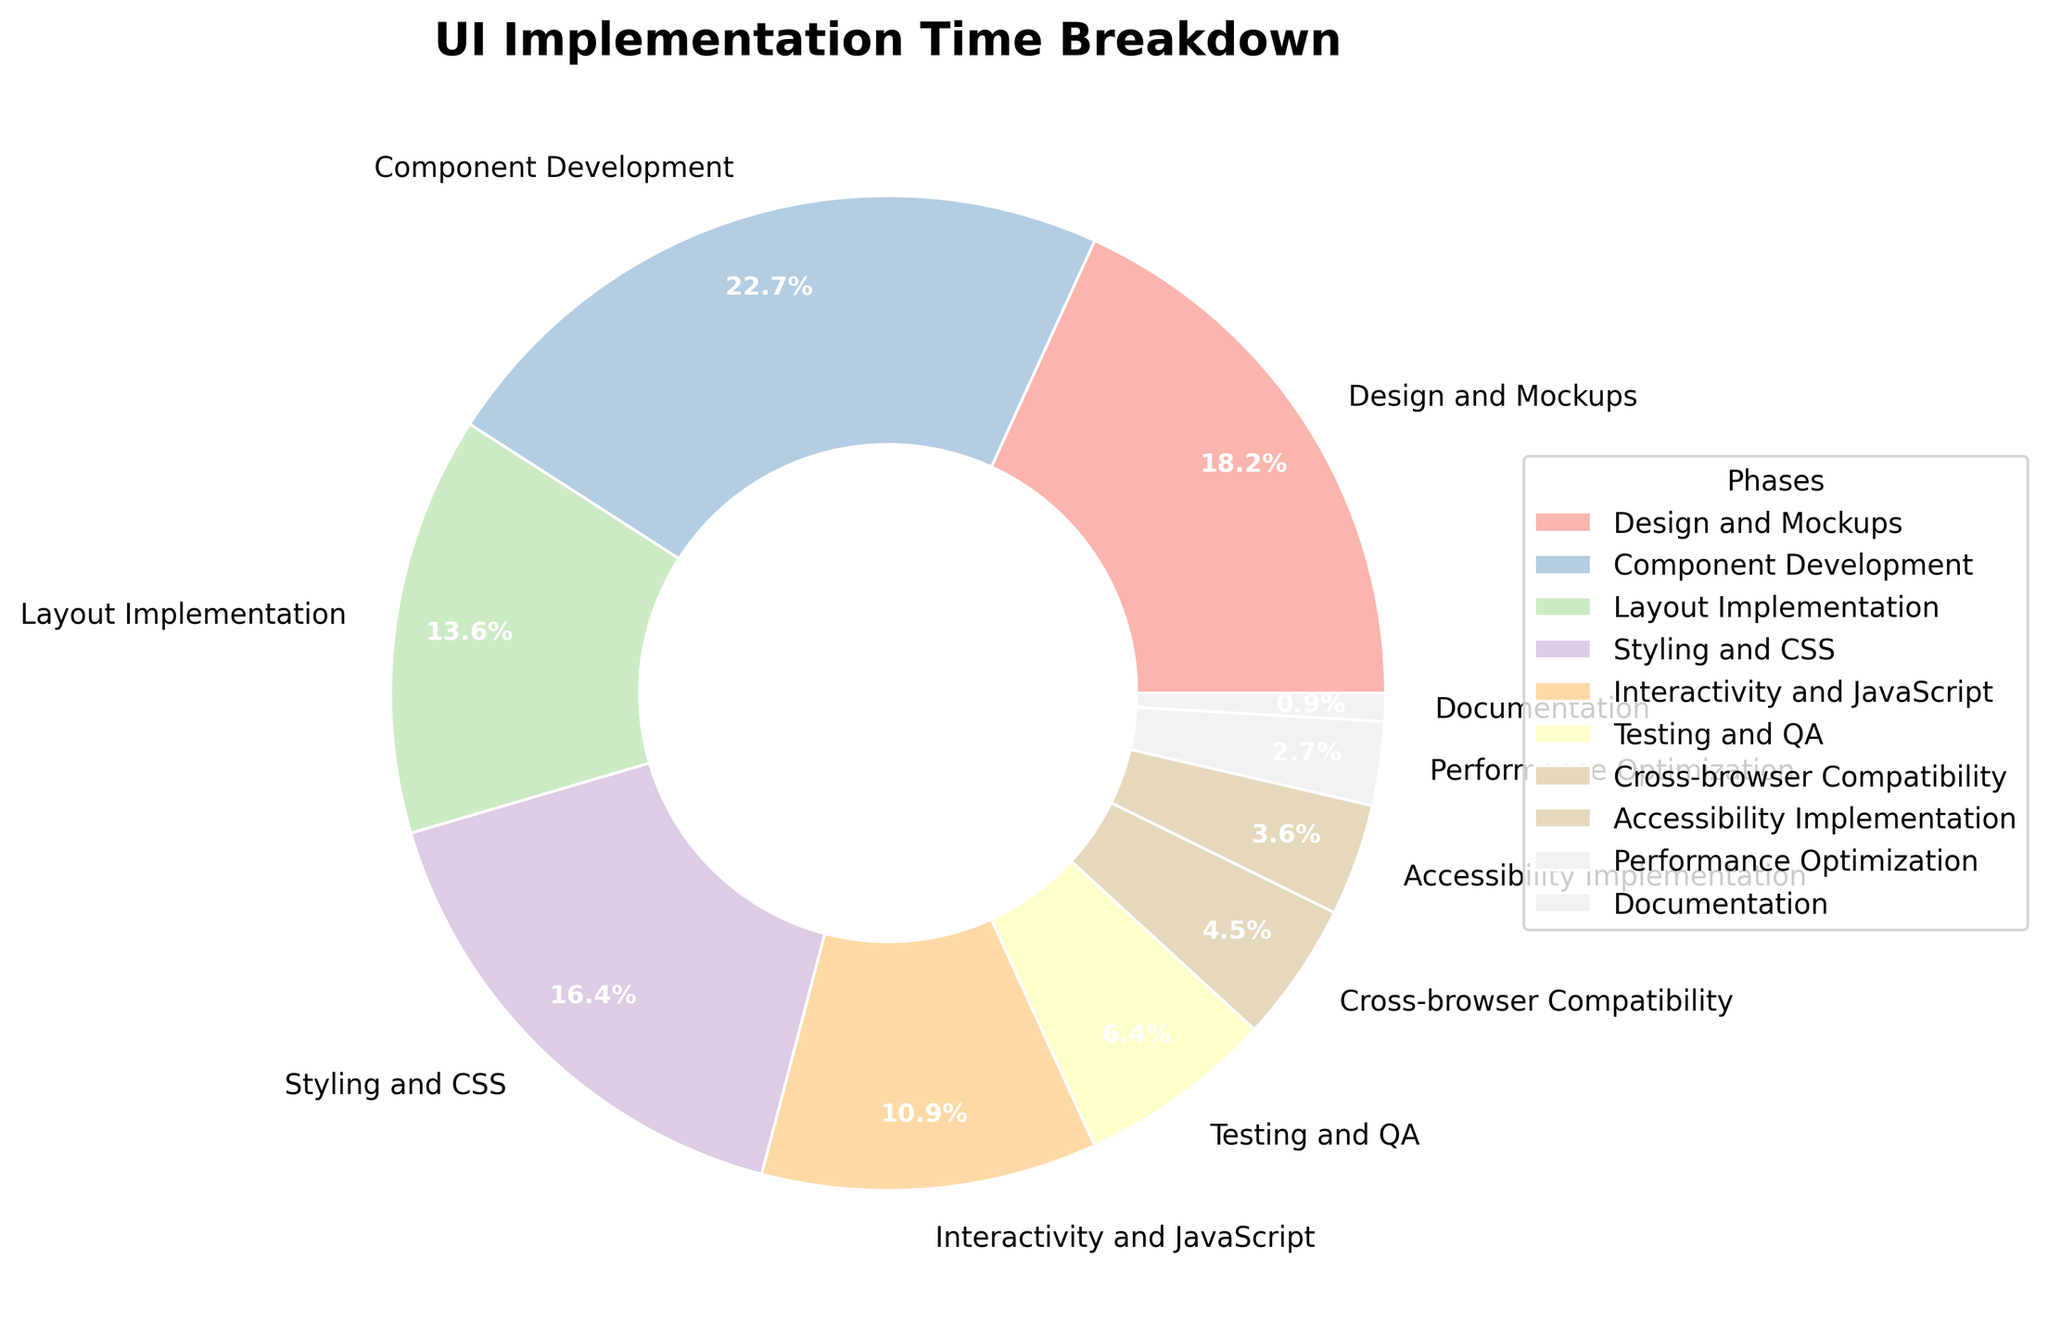Which phase takes the most time for UI implementation? The phase with the largest percentage in the pie chart. Component Development has the highest slice size, representing 25% of the total time.
Answer: Component Development Which phase takes the least time for UI implementation? The phase with the smallest percentage in the pie chart. Documentation has the smallest slice, representing only 1% of the total time.
Answer: Documentation What is the cumulative percentage of time spent on Testing and QA and Cross-browser Compatibility? Add the percentages for Testing and QA (7%) and Cross-browser Compatibility (5%). 7% + 5% = 12%
Answer: 12% How much more time is spent on Component Development compared to Performance Optimization? Subtract the percentage of time spent on Performance Optimization (3%) from that on Component Development (25%). 25% - 3% = 22%
Answer: 22% Which phase associated with CSS takes up 18% of the time? Identify the phase related to CSS and verify its percentage in the chart. Styling and CSS takes up 18% of the total time.
Answer: Styling and CSS Which phase's time percentage is closest to the median value? (Assuming there are 10 phases) Arrange the percentages in ascending order (1%, 3%, 4%, 5%, 7%, 12%, 15%, 18%, 20%, 25%) and find the median value, which is the average of the 5th and 6th elements: (7% + 12%) / 2 = 9.5%. Testing and QA at 7% and Interactivity and JavaScript at 12% are closest to the median.
Answer: Testing and QA and Interactivity and JavaScript How much time is spent on Design and Mockups and Layout Implementation together? Add the percentages for Design and Mockups (20%) and Layout Implementation (15%). 20% + 15% = 35%
Answer: 35% Which phase is represented by the largest slice in the pie chart? Identify the phase with the largest wedge in the pie chart visually. Component Development has the largest slice.
Answer: Component Development What is the percentage difference between Styling and CSS and Accessibility Implementation? Subtract the percentage of Accessibility Implementation (4%) from that of Styling and CSS (18%). 18% - 4% = 14%
Answer: 14% What color represents Testing and QA in the chart? Visually locate the slice for Testing and QA in the pie chart and identify its color from the custom colors used. Testing and QA is in a pastel shade.
Answer: Pastel shade 